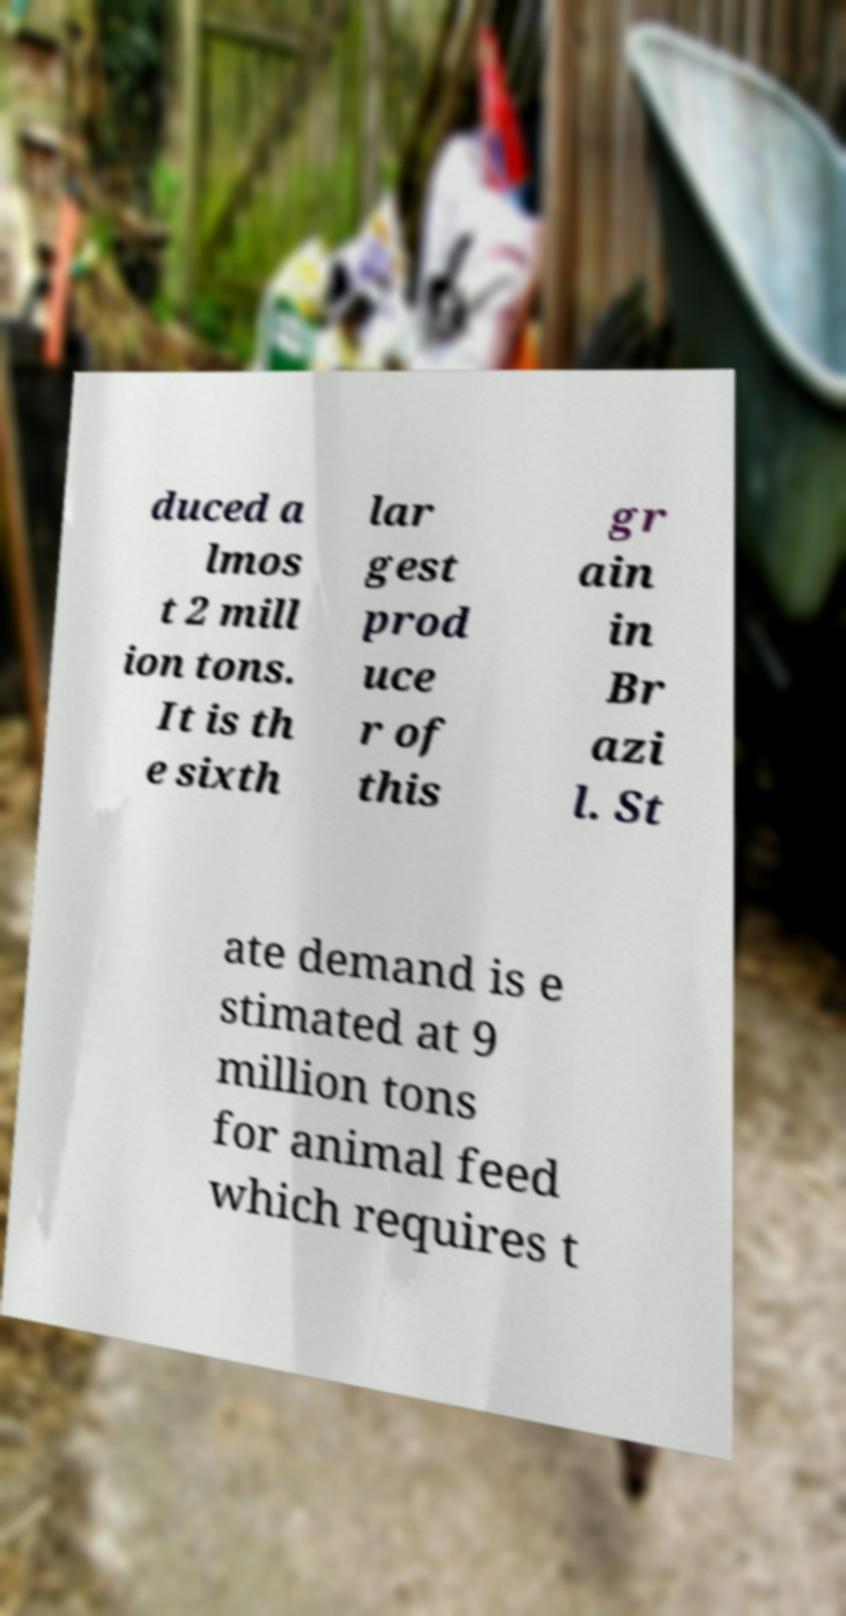Can you accurately transcribe the text from the provided image for me? duced a lmos t 2 mill ion tons. It is th e sixth lar gest prod uce r of this gr ain in Br azi l. St ate demand is e stimated at 9 million tons for animal feed which requires t 